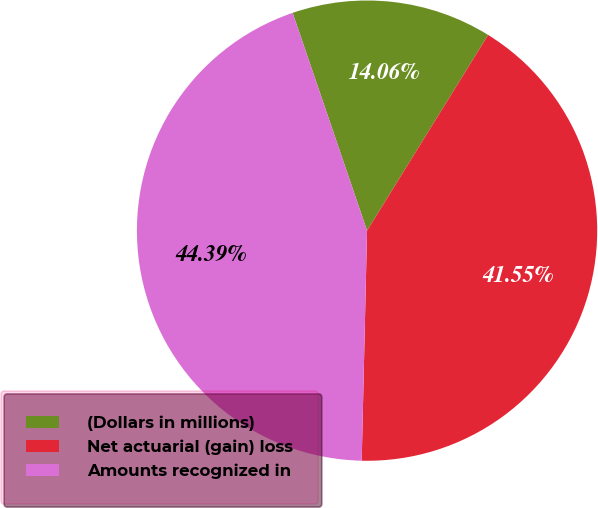Convert chart. <chart><loc_0><loc_0><loc_500><loc_500><pie_chart><fcel>(Dollars in millions)<fcel>Net actuarial (gain) loss<fcel>Amounts recognized in<nl><fcel>14.06%<fcel>41.55%<fcel>44.39%<nl></chart> 